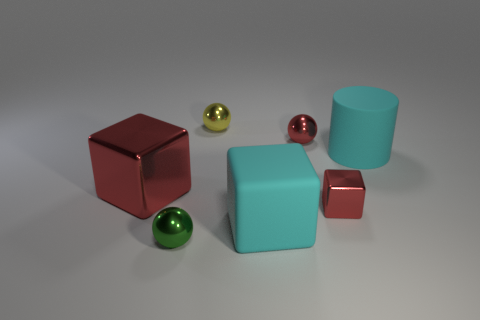Add 3 small cyan blocks. How many objects exist? 10 Subtract all cubes. How many objects are left? 4 Subtract all tiny yellow rubber blocks. Subtract all small green metallic balls. How many objects are left? 6 Add 2 tiny spheres. How many tiny spheres are left? 5 Add 4 small objects. How many small objects exist? 8 Subtract 1 green balls. How many objects are left? 6 